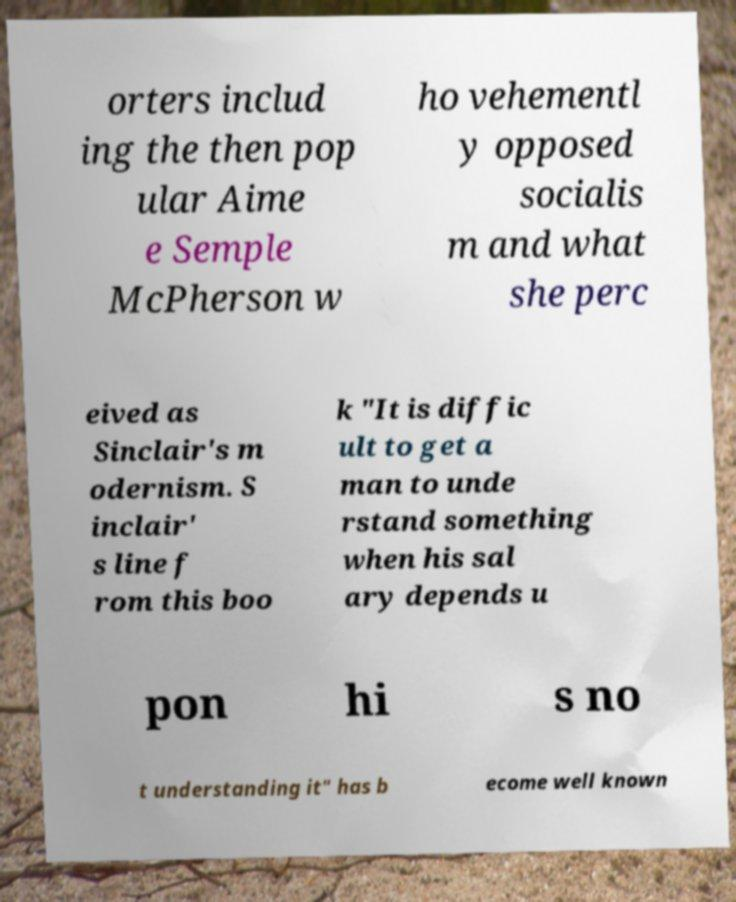Could you assist in decoding the text presented in this image and type it out clearly? orters includ ing the then pop ular Aime e Semple McPherson w ho vehementl y opposed socialis m and what she perc eived as Sinclair's m odernism. S inclair' s line f rom this boo k "It is diffic ult to get a man to unde rstand something when his sal ary depends u pon hi s no t understanding it" has b ecome well known 